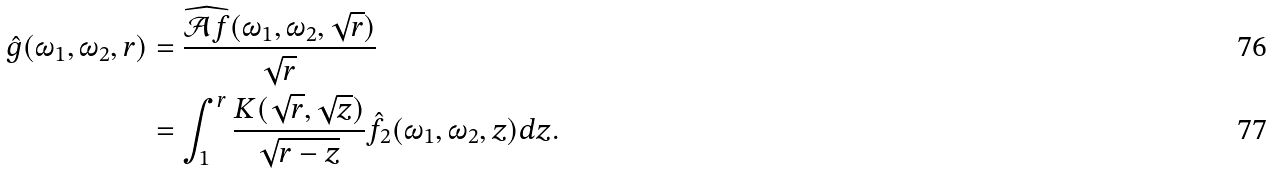<formula> <loc_0><loc_0><loc_500><loc_500>\hat { g } ( \omega _ { 1 } , \omega _ { 2 } , r ) & = \frac { \widehat { \mathcal { A } f } ( \omega _ { 1 } , \omega _ { 2 } , \sqrt { r } ) } { \sqrt { r } } \\ & = \int _ { 1 } ^ { r } \frac { K ( \sqrt { r } , \sqrt { z } ) } { \sqrt { r - z } } \hat { f _ { 2 } } ( \omega _ { 1 } , \omega _ { 2 } , z ) d z .</formula> 